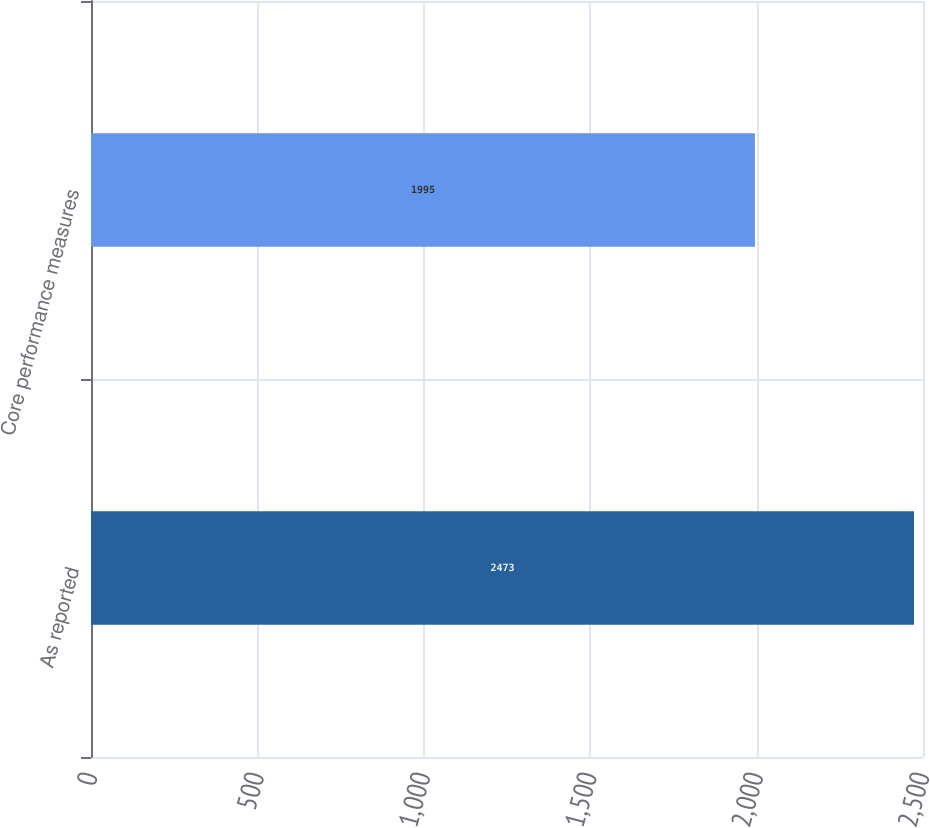Convert chart to OTSL. <chart><loc_0><loc_0><loc_500><loc_500><bar_chart><fcel>As reported<fcel>Core performance measures<nl><fcel>2473<fcel>1995<nl></chart> 